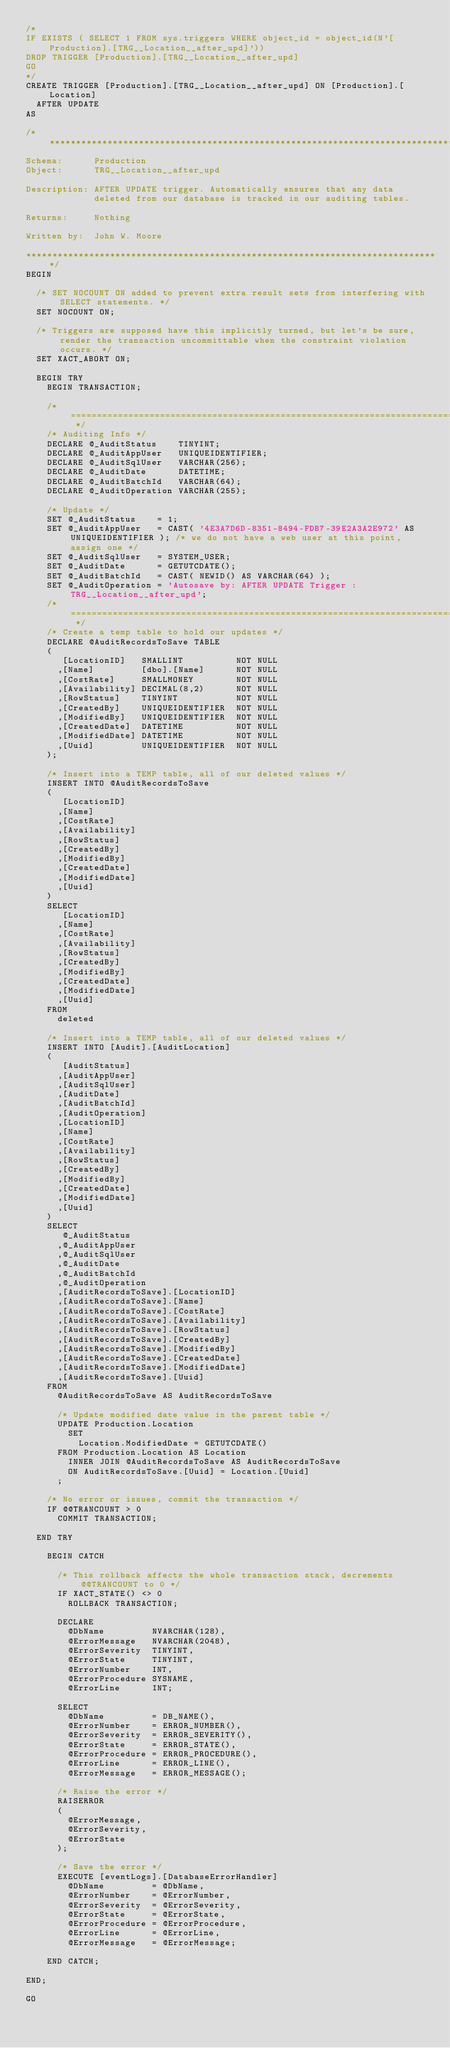Convert code to text. <code><loc_0><loc_0><loc_500><loc_500><_SQL_>/*
IF EXISTS ( SELECT 1 FROM sys.triggers WHERE object_id = object_id(N'[Production].[TRG__Location__after_upd]'))
DROP TRIGGER [Production].[TRG__Location__after_upd]
GO
*/
CREATE TRIGGER [Production].[TRG__Location__after_upd] ON [Production].[Location]
  AFTER UPDATE
AS

/*******************************************************************************
Schema:      Production
Object:      TRG__Location__after_upd

Description: AFTER UPDATE trigger. Automatically ensures that any data
             deleted from our database is tracked in our auditing tables.
             
Returns:     Nothing

Written by:  John W. Moore

*******************************************************************************/
BEGIN

  /* SET NOCOUNT ON added to prevent extra result sets from interfering with SELECT statements. */
  SET NOCOUNT ON;

  /* Triggers are supposed have this implicitly turned, but let's be sure, render the transaction uncommittable when the constraint violation occurs. */
  SET XACT_ABORT ON;

  BEGIN TRY
    BEGIN TRANSACTION;

    /* ========================================================================= */
    /* Auditing Info */
    DECLARE @_AuditStatus    TINYINT;
    DECLARE @_AuditAppUser   UNIQUEIDENTIFIER;
    DECLARE @_AuditSqlUser   VARCHAR(256);
    DECLARE @_AuditDate      DATETIME;
    DECLARE @_AuditBatchId   VARCHAR(64);
    DECLARE @_AuditOperation VARCHAR(255);

    /* Update */
    SET @_AuditStatus    = 1; 
    SET @_AuditAppUser   = CAST( '4E3A7D6D-8351-8494-FDB7-39E2A3A2E972' AS UNIQUEIDENTIFIER ); /* we do not have a web user at this point, assign one */
    SET @_AuditSqlUser   = SYSTEM_USER;
    SET @_AuditDate      = GETUTCDATE();
    SET @_AuditBatchId   = CAST( NEWID() AS VARCHAR(64) );
    SET @_AuditOperation = 'Autosave by: AFTER UPDATE Trigger : TRG__Location__after_upd';
    /* ========================================================================= */
    /* Create a temp table to hold our updates */
    DECLARE @AuditRecordsToSave TABLE
    (
       [LocationID]   SMALLINT          NOT NULL
      ,[Name]         [dbo].[Name]      NOT NULL
      ,[CostRate]     SMALLMONEY        NOT NULL
      ,[Availability] DECIMAL(8,2)      NOT NULL
      ,[RowStatus]    TINYINT           NOT NULL
      ,[CreatedBy]    UNIQUEIDENTIFIER  NOT NULL
      ,[ModifiedBy]   UNIQUEIDENTIFIER  NOT NULL
      ,[CreatedDate]  DATETIME          NOT NULL
      ,[ModifiedDate] DATETIME          NOT NULL
      ,[Uuid]         UNIQUEIDENTIFIER  NOT NULL
    );

    /* Insert into a TEMP table, all of our deleted values */
    INSERT INTO @AuditRecordsToSave
    (
       [LocationID]
      ,[Name]
      ,[CostRate]
      ,[Availability]
      ,[RowStatus]
      ,[CreatedBy]
      ,[ModifiedBy]
      ,[CreatedDate]
      ,[ModifiedDate]
      ,[Uuid]
    )
    SELECT
       [LocationID]
      ,[Name]
      ,[CostRate]
      ,[Availability]
      ,[RowStatus]
      ,[CreatedBy]
      ,[ModifiedBy]
      ,[CreatedDate]
      ,[ModifiedDate]
      ,[Uuid]
    FROM
      deleted

    /* Insert into a TEMP table, all of our deleted values */
    INSERT INTO [Audit].[AuditLocation]
    (
       [AuditStatus]
      ,[AuditAppUser]
      ,[AuditSqlUser]
      ,[AuditDate]
      ,[AuditBatchId]
      ,[AuditOperation]
      ,[LocationID]
      ,[Name]
      ,[CostRate]
      ,[Availability]
      ,[RowStatus]
      ,[CreatedBy]
      ,[ModifiedBy]
      ,[CreatedDate]
      ,[ModifiedDate]
      ,[Uuid]
    )
    SELECT
       @_AuditStatus
      ,@_AuditAppUser
      ,@_AuditSqlUser
      ,@_AuditDate
      ,@_AuditBatchId
      ,@_AuditOperation
      ,[AuditRecordsToSave].[LocationID]
      ,[AuditRecordsToSave].[Name]
      ,[AuditRecordsToSave].[CostRate]
      ,[AuditRecordsToSave].[Availability]
      ,[AuditRecordsToSave].[RowStatus]
      ,[AuditRecordsToSave].[CreatedBy]
      ,[AuditRecordsToSave].[ModifiedBy]
      ,[AuditRecordsToSave].[CreatedDate]
      ,[AuditRecordsToSave].[ModifiedDate]
      ,[AuditRecordsToSave].[Uuid]
    FROM
      @AuditRecordsToSave AS AuditRecordsToSave

      /* Update modified date value in the parent table */
      UPDATE Production.Location
        SET
          Location.ModifiedDate = GETUTCDATE()
      FROM Production.Location AS Location
        INNER JOIN @AuditRecordsToSave AS AuditRecordsToSave
        ON AuditRecordsToSave.[Uuid] = Location.[Uuid]
      ;

    /* No error or issues, commit the transaction */
    IF @@TRANCOUNT > 0 
      COMMIT TRANSACTION;

  END TRY

    BEGIN CATCH

      /* This rollback affects the whole transaction stack, decrements @@TRANCOUNT to 0 */
      IF XACT_STATE() <> 0
        ROLLBACK TRANSACTION;

      DECLARE
        @DbName         NVARCHAR(128),
        @ErrorMessage   NVARCHAR(2048),
        @ErrorSeverity  TINYINT,
        @ErrorState     TINYINT,
        @ErrorNumber    INT,
        @ErrorProcedure SYSNAME,
        @ErrorLine      INT;

      SELECT
        @DbName         = DB_NAME(),
        @ErrorNumber    = ERROR_NUMBER(),
        @ErrorSeverity  = ERROR_SEVERITY(),
        @ErrorState     = ERROR_STATE(),
        @ErrorProcedure = ERROR_PROCEDURE(),
        @ErrorLine      = ERROR_LINE(),
        @ErrorMessage   = ERROR_MESSAGE();

      /* Raise the error */
      RAISERROR
      (
        @ErrorMessage,
        @ErrorSeverity,
        @ErrorState
      );

      /* Save the error */
      EXECUTE [eventLogs].[DatabaseErrorHandler]
        @DbName         = @DbName,
        @ErrorNumber    = @ErrorNumber,
        @ErrorSeverity  = @ErrorSeverity,
        @ErrorState     = @ErrorState,
        @ErrorProcedure = @ErrorProcedure,
        @ErrorLine      = @ErrorLine,
        @ErrorMessage   = @ErrorMessage;

    END CATCH;

END;

GO</code> 